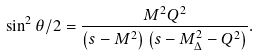Convert formula to latex. <formula><loc_0><loc_0><loc_500><loc_500>\sin ^ { 2 } \theta / 2 = \frac { M ^ { 2 } Q ^ { 2 } } { \left ( s - M ^ { 2 } \right ) \left ( s - M _ { \Delta } ^ { 2 } - Q ^ { 2 } \right ) } .</formula> 